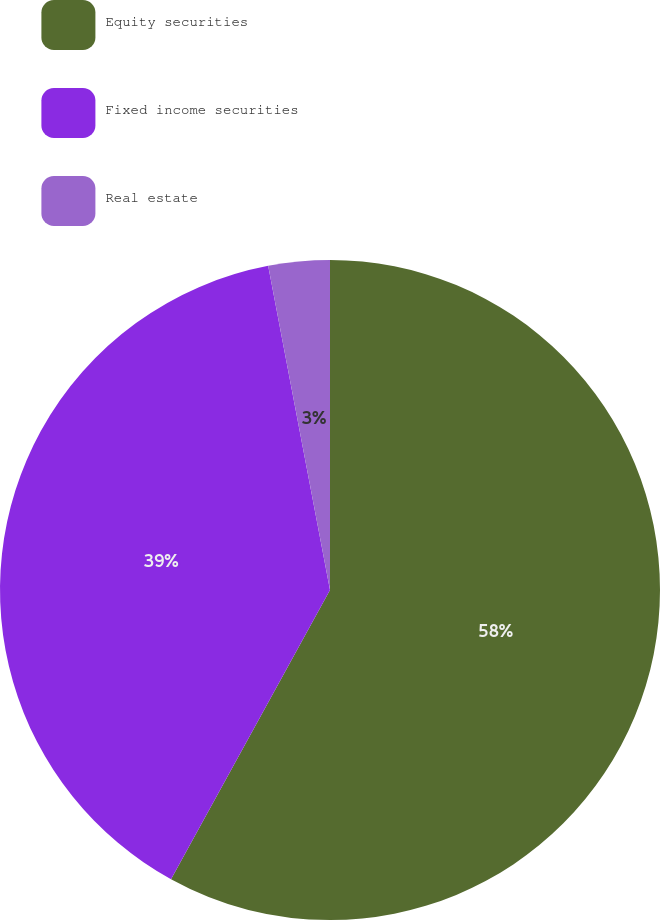<chart> <loc_0><loc_0><loc_500><loc_500><pie_chart><fcel>Equity securities<fcel>Fixed income securities<fcel>Real estate<nl><fcel>58.0%<fcel>39.0%<fcel>3.0%<nl></chart> 